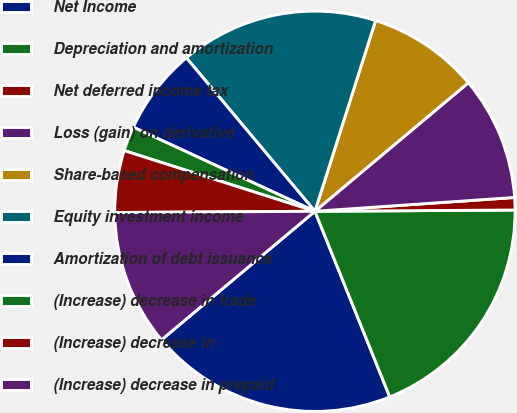Convert chart to OTSL. <chart><loc_0><loc_0><loc_500><loc_500><pie_chart><fcel>Net Income<fcel>Depreciation and amortization<fcel>Net deferred income tax<fcel>Loss (gain) on derivative<fcel>Share-based compensation<fcel>Equity investment income<fcel>Amortization of debt issuance<fcel>(Increase) decrease in trade<fcel>(Increase) decrease in<fcel>(Increase) decrease in prepaid<nl><fcel>20.0%<fcel>19.0%<fcel>1.0%<fcel>10.0%<fcel>9.0%<fcel>16.0%<fcel>7.0%<fcel>2.0%<fcel>5.0%<fcel>11.0%<nl></chart> 